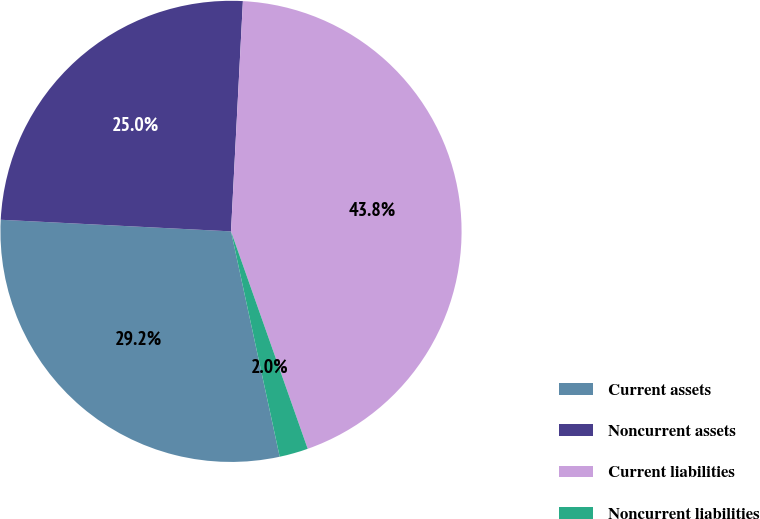Convert chart to OTSL. <chart><loc_0><loc_0><loc_500><loc_500><pie_chart><fcel>Current assets<fcel>Noncurrent assets<fcel>Current liabilities<fcel>Noncurrent liabilities<nl><fcel>29.19%<fcel>25.02%<fcel>43.78%<fcel>2.01%<nl></chart> 